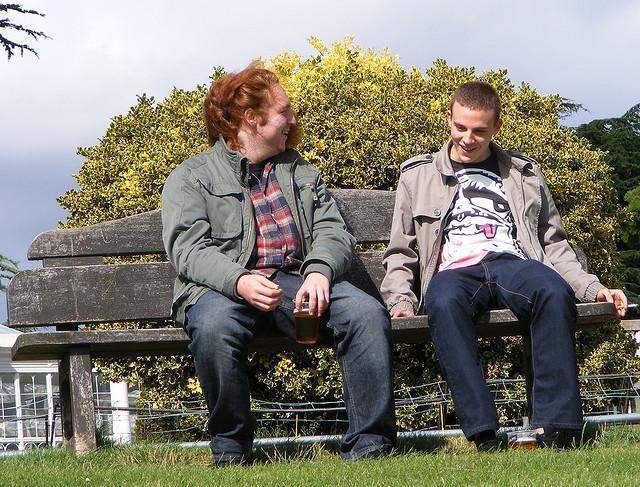What are the men sitting on?
From the following set of four choices, select the accurate answer to respond to the question.
Options: Bench, grass, boulder, log. Bench. 